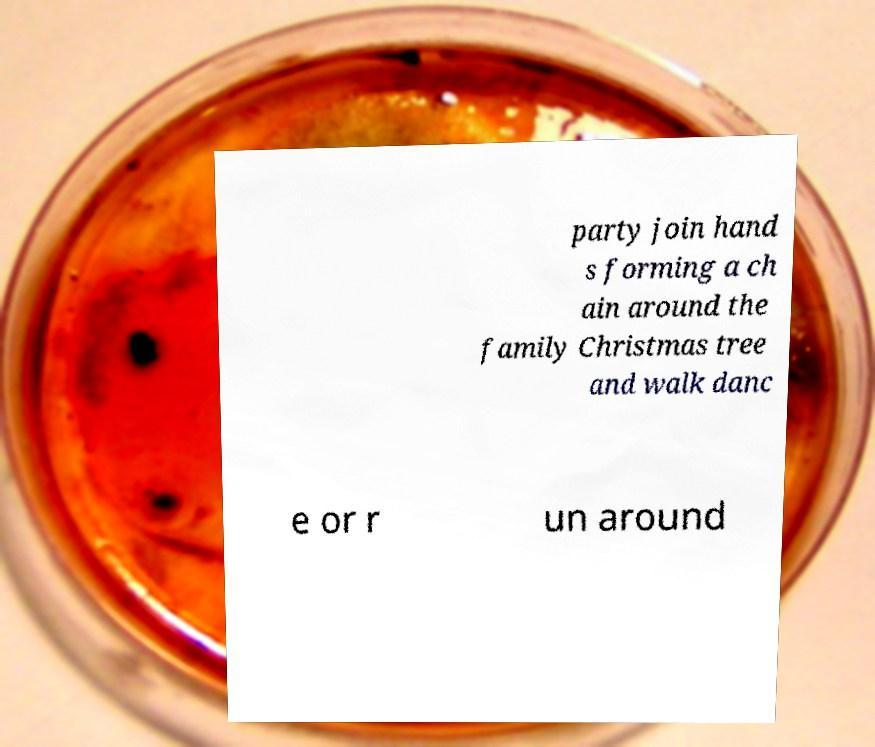Can you accurately transcribe the text from the provided image for me? party join hand s forming a ch ain around the family Christmas tree and walk danc e or r un around 